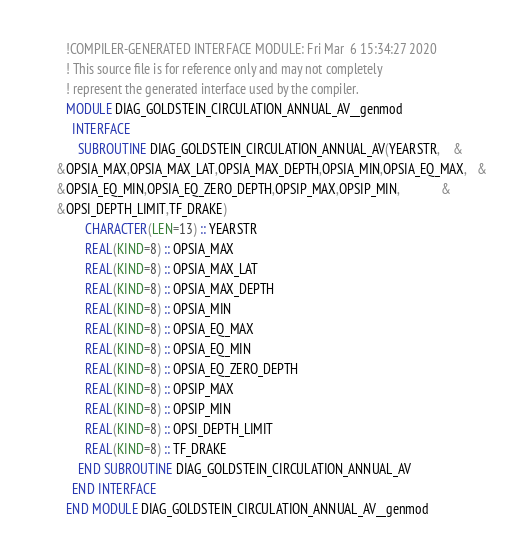Convert code to text. <code><loc_0><loc_0><loc_500><loc_500><_FORTRAN_>        !COMPILER-GENERATED INTERFACE MODULE: Fri Mar  6 15:34:27 2020
        ! This source file is for reference only and may not completely
        ! represent the generated interface used by the compiler.
        MODULE DIAG_GOLDSTEIN_CIRCULATION_ANNUAL_AV__genmod
          INTERFACE 
            SUBROUTINE DIAG_GOLDSTEIN_CIRCULATION_ANNUAL_AV(YEARSTR,    &
     &OPSIA_MAX,OPSIA_MAX_LAT,OPSIA_MAX_DEPTH,OPSIA_MIN,OPSIA_EQ_MAX,   &
     &OPSIA_EQ_MIN,OPSIA_EQ_ZERO_DEPTH,OPSIP_MAX,OPSIP_MIN,             &
     &OPSI_DEPTH_LIMIT,TF_DRAKE)
              CHARACTER(LEN=13) :: YEARSTR
              REAL(KIND=8) :: OPSIA_MAX
              REAL(KIND=8) :: OPSIA_MAX_LAT
              REAL(KIND=8) :: OPSIA_MAX_DEPTH
              REAL(KIND=8) :: OPSIA_MIN
              REAL(KIND=8) :: OPSIA_EQ_MAX
              REAL(KIND=8) :: OPSIA_EQ_MIN
              REAL(KIND=8) :: OPSIA_EQ_ZERO_DEPTH
              REAL(KIND=8) :: OPSIP_MAX
              REAL(KIND=8) :: OPSIP_MIN
              REAL(KIND=8) :: OPSI_DEPTH_LIMIT
              REAL(KIND=8) :: TF_DRAKE
            END SUBROUTINE DIAG_GOLDSTEIN_CIRCULATION_ANNUAL_AV
          END INTERFACE 
        END MODULE DIAG_GOLDSTEIN_CIRCULATION_ANNUAL_AV__genmod
</code> 